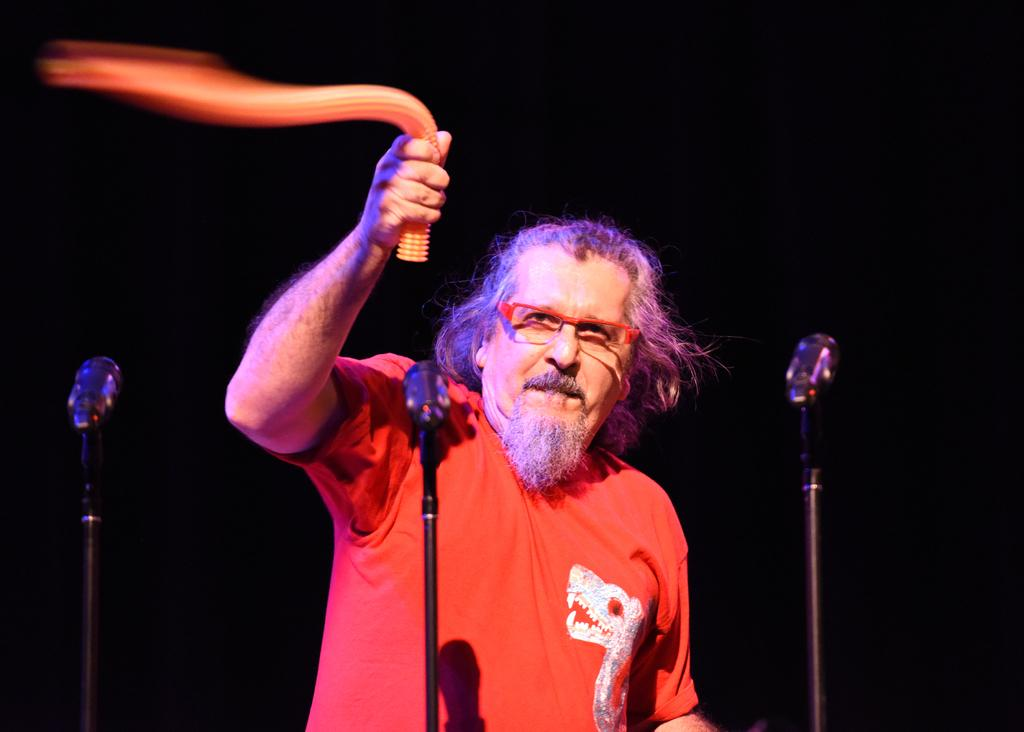Who is the main subject in the image? There is a man in the image. What is the man doing in the image? The man is standing in front of microphones. What is the man holding in his hand? The man is holding an object in his hand. What can be observed about the background of the image? The background of the image is dark. What type of underwear is the man wearing in the image? There is no information about the man's underwear in the image, so it cannot be determined. Can you hear any bells ringing in the image? There is no sound in the image, so it is not possible to hear any bells ringing. 